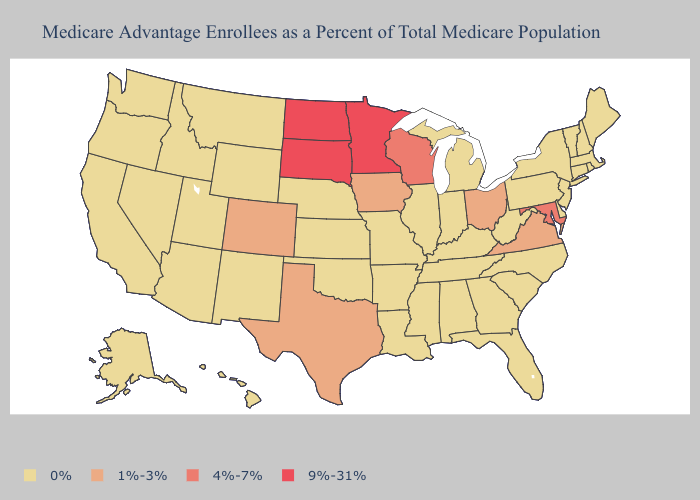Which states hav the highest value in the Northeast?
Write a very short answer. Connecticut, Massachusetts, Maine, New Hampshire, New Jersey, New York, Pennsylvania, Rhode Island, Vermont. Does Virginia have the lowest value in the South?
Keep it brief. No. Is the legend a continuous bar?
Short answer required. No. Is the legend a continuous bar?
Write a very short answer. No. Name the states that have a value in the range 1%-3%?
Write a very short answer. Colorado, Iowa, Ohio, Texas, Virginia. Name the states that have a value in the range 9%-31%?
Concise answer only. Minnesota, North Dakota, South Dakota. Is the legend a continuous bar?
Write a very short answer. No. Does the first symbol in the legend represent the smallest category?
Answer briefly. Yes. Does Colorado have the highest value in the West?
Keep it brief. Yes. Does North Dakota have the same value as Indiana?
Concise answer only. No. What is the highest value in the USA?
Keep it brief. 9%-31%. Name the states that have a value in the range 9%-31%?
Quick response, please. Minnesota, North Dakota, South Dakota. Does the map have missing data?
Give a very brief answer. No. Which states have the lowest value in the USA?
Answer briefly. Alaska, Alabama, Arkansas, Arizona, California, Connecticut, Delaware, Florida, Georgia, Hawaii, Idaho, Illinois, Indiana, Kansas, Kentucky, Louisiana, Massachusetts, Maine, Michigan, Missouri, Mississippi, Montana, North Carolina, Nebraska, New Hampshire, New Jersey, New Mexico, Nevada, New York, Oklahoma, Oregon, Pennsylvania, Rhode Island, South Carolina, Tennessee, Utah, Vermont, Washington, West Virginia, Wyoming. Name the states that have a value in the range 9%-31%?
Be succinct. Minnesota, North Dakota, South Dakota. 